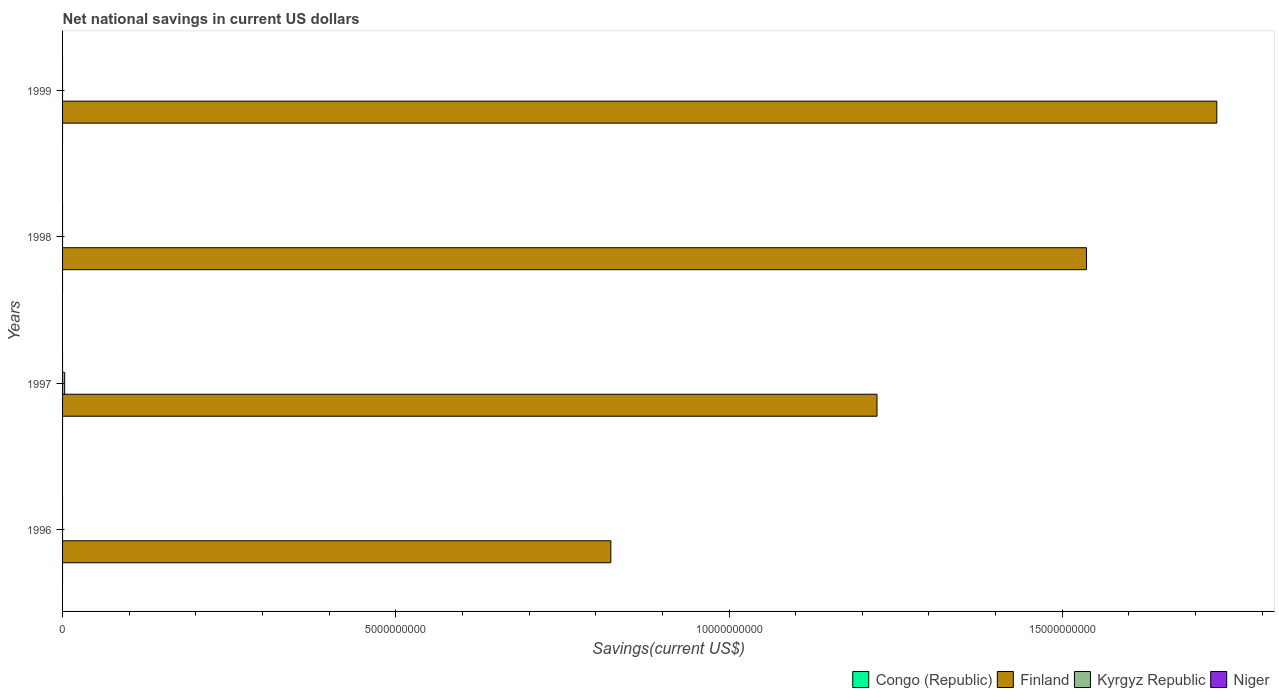How many different coloured bars are there?
Offer a very short reply. 2. Are the number of bars per tick equal to the number of legend labels?
Offer a terse response. No. Are the number of bars on each tick of the Y-axis equal?
Provide a succinct answer. No. How many bars are there on the 4th tick from the bottom?
Provide a succinct answer. 1. What is the label of the 3rd group of bars from the top?
Offer a very short reply. 1997. In how many cases, is the number of bars for a given year not equal to the number of legend labels?
Give a very brief answer. 4. Across all years, what is the maximum net national savings in Kyrgyz Republic?
Give a very brief answer. 3.15e+07. What is the difference between the net national savings in Finland in 1996 and that in 1999?
Your response must be concise. -9.09e+09. In the year 1997, what is the difference between the net national savings in Kyrgyz Republic and net national savings in Finland?
Offer a terse response. -1.22e+1. What is the ratio of the net national savings in Finland in 1996 to that in 1997?
Provide a succinct answer. 0.67. What is the difference between the highest and the second highest net national savings in Finland?
Offer a very short reply. 1.96e+09. What is the difference between the highest and the lowest net national savings in Kyrgyz Republic?
Offer a terse response. 3.15e+07. In how many years, is the net national savings in Kyrgyz Republic greater than the average net national savings in Kyrgyz Republic taken over all years?
Give a very brief answer. 1. Is the sum of the net national savings in Finland in 1996 and 1999 greater than the maximum net national savings in Niger across all years?
Your answer should be very brief. Yes. Is it the case that in every year, the sum of the net national savings in Congo (Republic) and net national savings in Kyrgyz Republic is greater than the sum of net national savings in Finland and net national savings in Niger?
Your answer should be compact. No. How many bars are there?
Provide a short and direct response. 5. Are all the bars in the graph horizontal?
Make the answer very short. Yes. How are the legend labels stacked?
Provide a succinct answer. Horizontal. What is the title of the graph?
Give a very brief answer. Net national savings in current US dollars. Does "Philippines" appear as one of the legend labels in the graph?
Make the answer very short. No. What is the label or title of the X-axis?
Offer a terse response. Savings(current US$). What is the Savings(current US$) in Finland in 1996?
Ensure brevity in your answer.  8.23e+09. What is the Savings(current US$) of Niger in 1996?
Keep it short and to the point. 0. What is the Savings(current US$) of Congo (Republic) in 1997?
Ensure brevity in your answer.  0. What is the Savings(current US$) in Finland in 1997?
Ensure brevity in your answer.  1.22e+1. What is the Savings(current US$) of Kyrgyz Republic in 1997?
Give a very brief answer. 3.15e+07. What is the Savings(current US$) of Niger in 1997?
Your response must be concise. 0. What is the Savings(current US$) of Finland in 1998?
Provide a succinct answer. 1.54e+1. What is the Savings(current US$) in Kyrgyz Republic in 1998?
Provide a short and direct response. 0. What is the Savings(current US$) in Niger in 1998?
Your answer should be compact. 0. What is the Savings(current US$) in Finland in 1999?
Provide a succinct answer. 1.73e+1. What is the Savings(current US$) of Kyrgyz Republic in 1999?
Your response must be concise. 0. Across all years, what is the maximum Savings(current US$) of Finland?
Your response must be concise. 1.73e+1. Across all years, what is the maximum Savings(current US$) in Kyrgyz Republic?
Ensure brevity in your answer.  3.15e+07. Across all years, what is the minimum Savings(current US$) of Finland?
Ensure brevity in your answer.  8.23e+09. Across all years, what is the minimum Savings(current US$) in Kyrgyz Republic?
Your answer should be very brief. 0. What is the total Savings(current US$) of Finland in the graph?
Provide a succinct answer. 5.31e+1. What is the total Savings(current US$) in Kyrgyz Republic in the graph?
Make the answer very short. 3.15e+07. What is the difference between the Savings(current US$) of Finland in 1996 and that in 1997?
Provide a short and direct response. -3.99e+09. What is the difference between the Savings(current US$) in Finland in 1996 and that in 1998?
Ensure brevity in your answer.  -7.14e+09. What is the difference between the Savings(current US$) of Finland in 1996 and that in 1999?
Your answer should be compact. -9.09e+09. What is the difference between the Savings(current US$) in Finland in 1997 and that in 1998?
Ensure brevity in your answer.  -3.14e+09. What is the difference between the Savings(current US$) of Finland in 1997 and that in 1999?
Provide a short and direct response. -5.10e+09. What is the difference between the Savings(current US$) of Finland in 1998 and that in 1999?
Your answer should be very brief. -1.96e+09. What is the difference between the Savings(current US$) of Finland in 1996 and the Savings(current US$) of Kyrgyz Republic in 1997?
Provide a succinct answer. 8.20e+09. What is the average Savings(current US$) in Finland per year?
Ensure brevity in your answer.  1.33e+1. What is the average Savings(current US$) in Kyrgyz Republic per year?
Offer a terse response. 7.89e+06. What is the average Savings(current US$) of Niger per year?
Offer a terse response. 0. In the year 1997, what is the difference between the Savings(current US$) in Finland and Savings(current US$) in Kyrgyz Republic?
Keep it short and to the point. 1.22e+1. What is the ratio of the Savings(current US$) in Finland in 1996 to that in 1997?
Ensure brevity in your answer.  0.67. What is the ratio of the Savings(current US$) in Finland in 1996 to that in 1998?
Your response must be concise. 0.54. What is the ratio of the Savings(current US$) of Finland in 1996 to that in 1999?
Offer a terse response. 0.47. What is the ratio of the Savings(current US$) in Finland in 1997 to that in 1998?
Your answer should be very brief. 0.8. What is the ratio of the Savings(current US$) in Finland in 1997 to that in 1999?
Provide a short and direct response. 0.71. What is the ratio of the Savings(current US$) of Finland in 1998 to that in 1999?
Provide a succinct answer. 0.89. What is the difference between the highest and the second highest Savings(current US$) of Finland?
Keep it short and to the point. 1.96e+09. What is the difference between the highest and the lowest Savings(current US$) in Finland?
Provide a succinct answer. 9.09e+09. What is the difference between the highest and the lowest Savings(current US$) in Kyrgyz Republic?
Ensure brevity in your answer.  3.15e+07. 